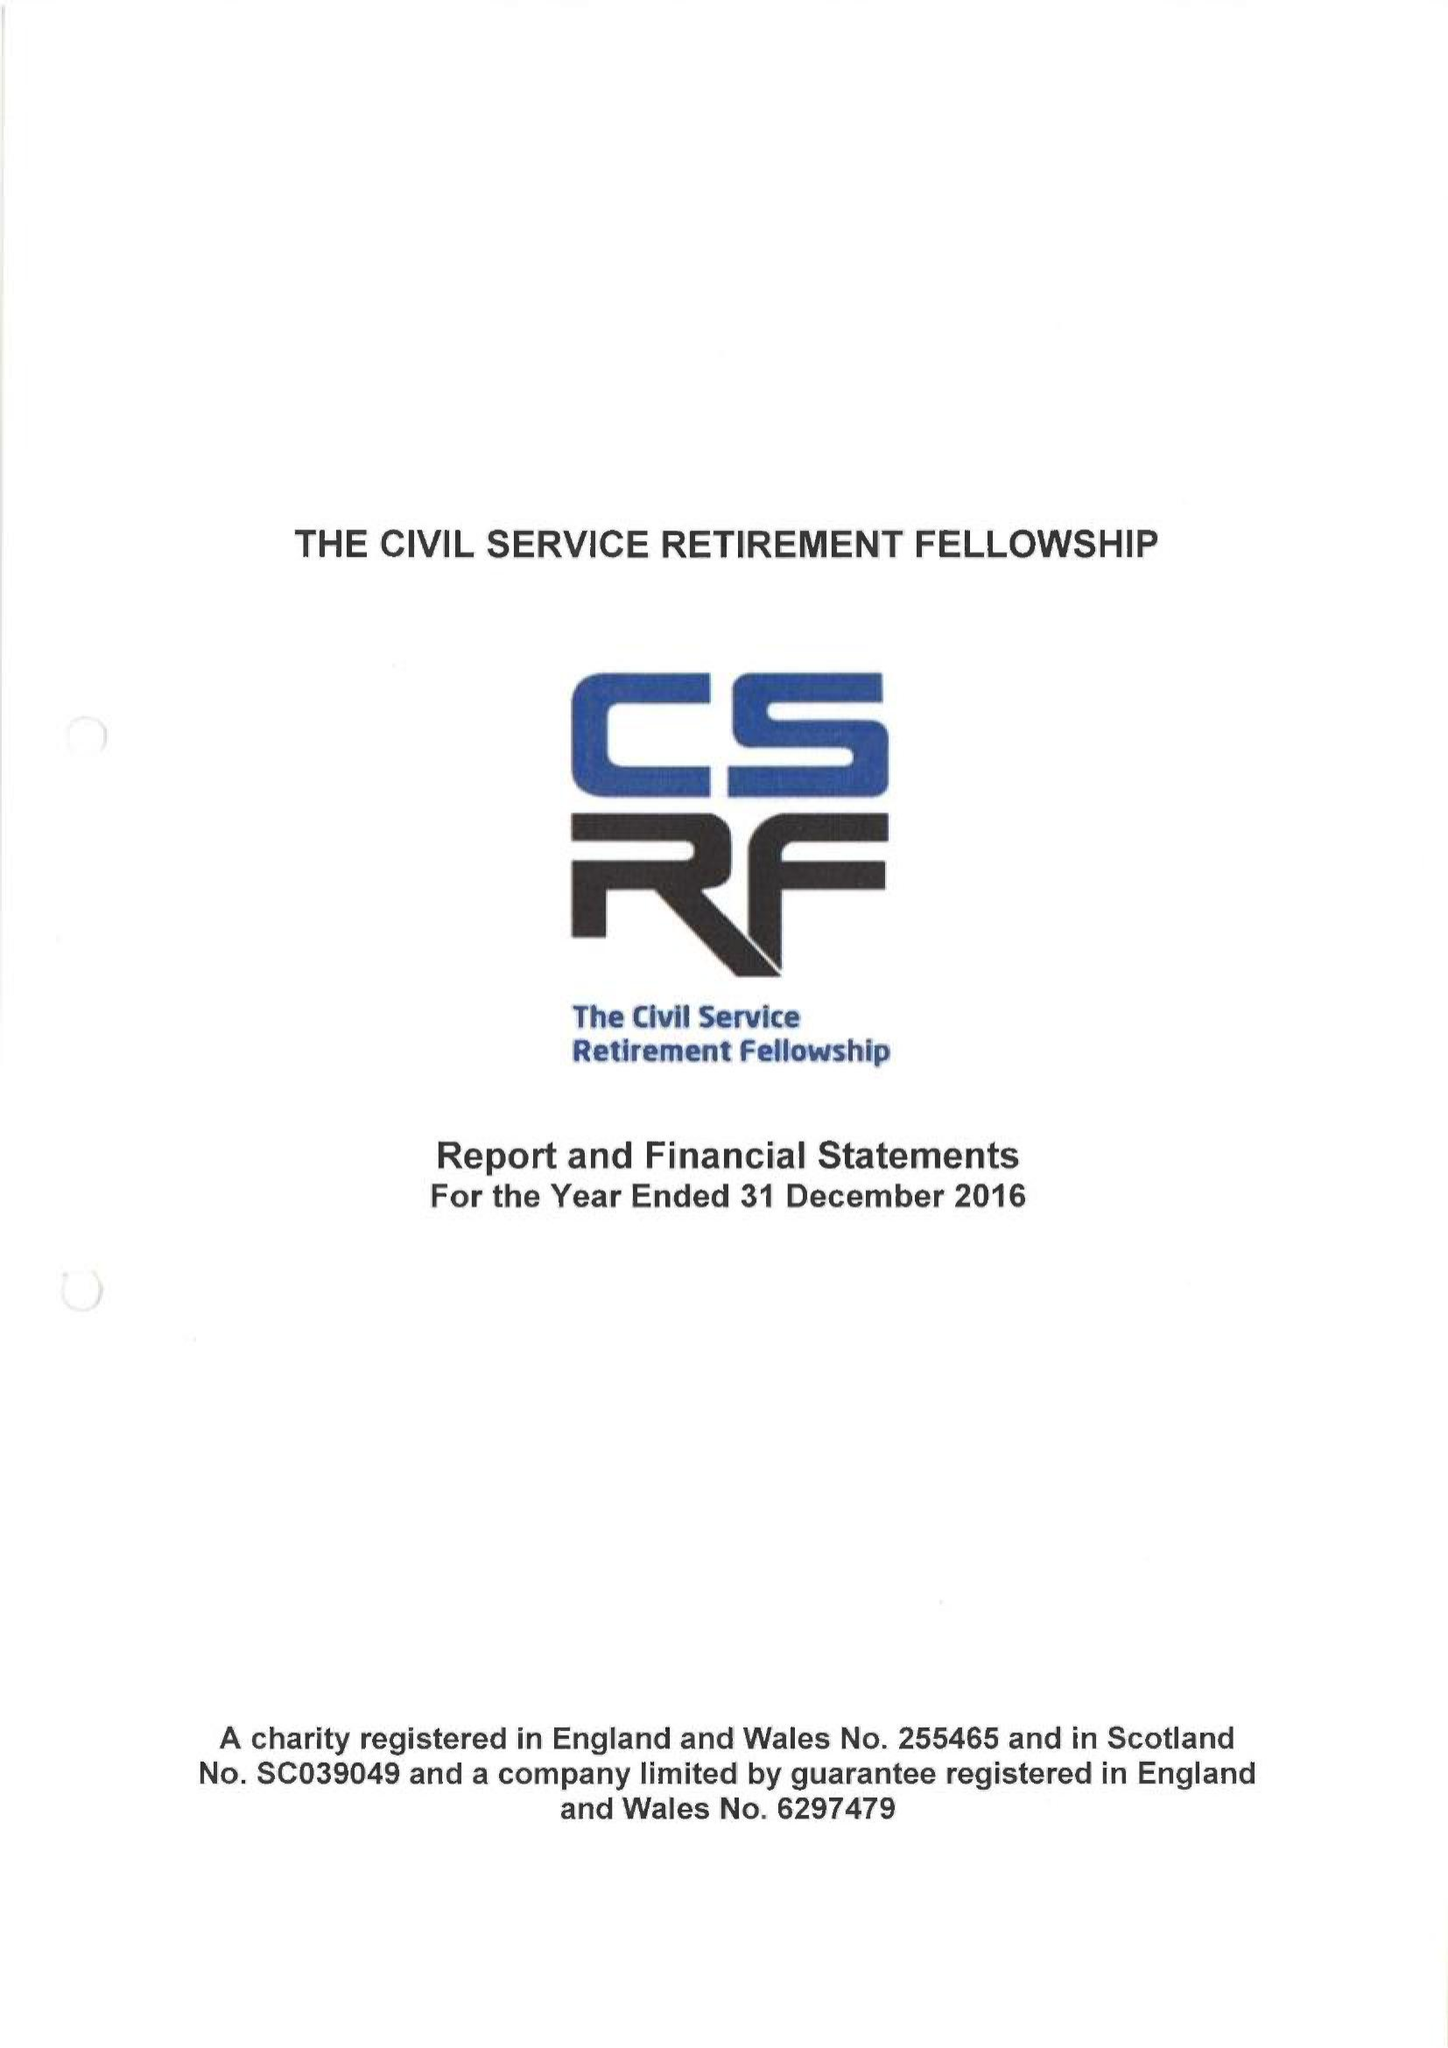What is the value for the spending_annually_in_british_pounds?
Answer the question using a single word or phrase. 451608.00 